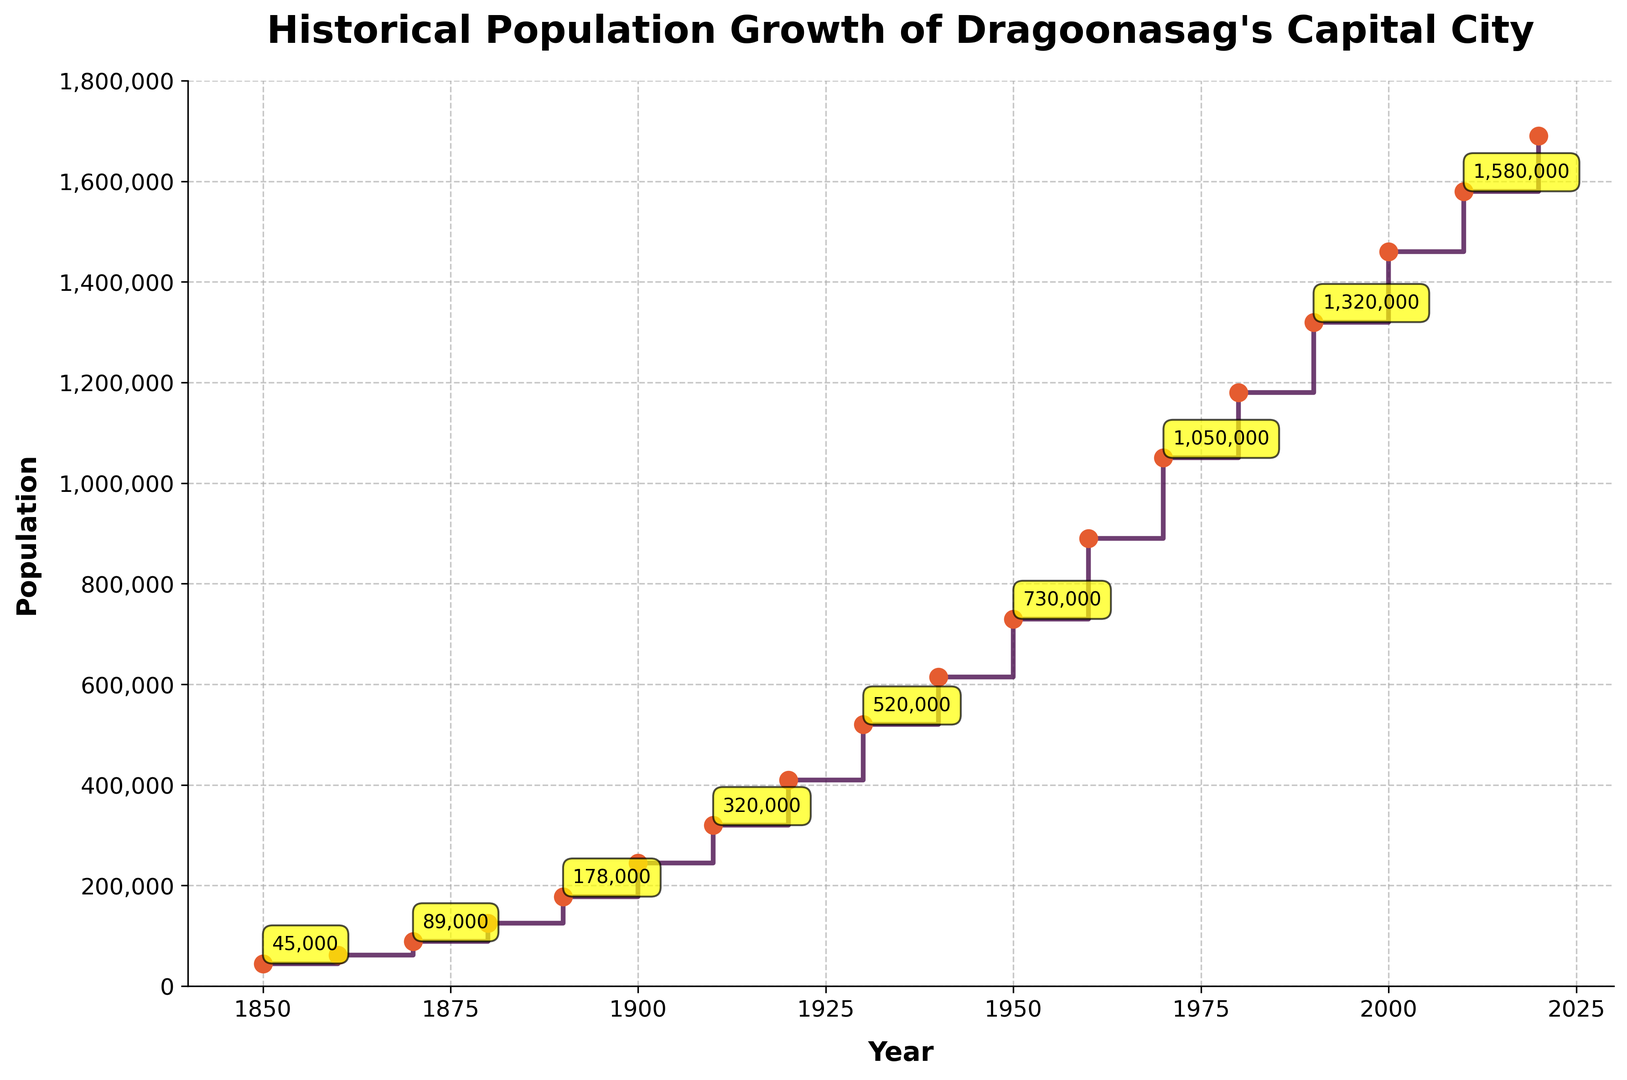What's the overall population growth from 1850 to 2020? To determine the overall population growth, subtract the population in 1850 from the population in 2020. This gives 1,690,000 - 45,000 = 1,645,000.
Answer: 1,645,000 Which decade saw the highest increase in population? Identify the decade with the highest difference between populations. Between 1890 and 1900, the population increased from 178,000 to 245,000, which is a difference of 67,000, larger than any other decade.
Answer: 1890-1900 Compare the population of 1900 with 1950. Which year had a higher population and by how much? Population in 1900 was 245,000 and in 1950 it was 730,000. To find the difference, subtract 245,000 from 730,000 giving 485,000.
Answer: 1950, by 485,000 Which decade saw a population increase of approximately 310,000? Between 1930 and 1940, the population increased from 520,000 to 615,000, which is a difference of 95,000. Between 1950 and 1960, the population increased from 730,000 to 890,000, which is a difference of 160,000. Between 1870 and 1880, the population increased from 89,000 to 125,000, which is a difference of 36,000. The closest decade that saw an increase of around 310,000 is from 1920 to 1930, increasing from 410,000 to 520,000, which is a difference of 110,000. Therefore, looking for a decade with precisely 310,000 would not apply within the available data.
Answer: No decade matched exactly How many decades experienced a population increase of more than 100,000? Review each decade’s population difference. From 1850-1860, 17,000; 1860-1870, 27,000; 1870-1880, 36,000; 1880-1890, 53,000; 1890-1900, 67,000; 1900-1910, 75,000; 1910-1920, 90,000; 1920-1930, 110,000; 1930-1940, 95,000; 1940-1950, 115,000; 1950-1960, 160,000; 1960-1970, 160,000; 1970-1980, 130,000; 1980-1990, 140,000; 1990-2000, 145,000; 2000-2010, 120,000; 2010-2020, 110,000. Count the decades over 100,000, which gives 9.
Answer: 9 What was the population in the year 2000? Find the year 2000 on the x-axis and read the corresponding population on the y-axis, which is 1,460,000.
Answer: 1,460,000 How did the population change between 1980 and 2010? In 1980, the population was 1,180,000, and in 2010, it was 1,580,000. Subtracting the earlier population from the latter gives 1,580,000 - 1,180,000 = 400,000.
Answer: Increased by 400,000 During which decade did the city experience the least growth? Identify the decade with the smallest change in population. From 1930 to 1940, the population grew by only 95,000, the smallest positive change when comparing all.
Answer: 1930-1940 In which decade did the capital city's population first exceed one million? Locate the year when the population crosses 1,000,000. This occurs between 1960 (890,000) and 1970 (1,050,000). Thus, the decade is 1970.
Answer: 1970 